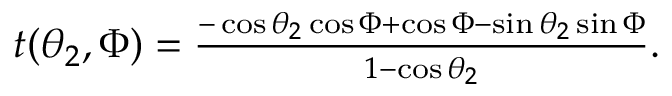Convert formula to latex. <formula><loc_0><loc_0><loc_500><loc_500>\begin{array} { r } { t ( \theta _ { 2 } , \Phi ) = \frac { - \cos \theta _ { 2 } \cos \Phi + \cos \Phi - \sin \theta _ { 2 } \sin \Phi } { 1 - \cos \theta _ { 2 } } . } \end{array}</formula> 